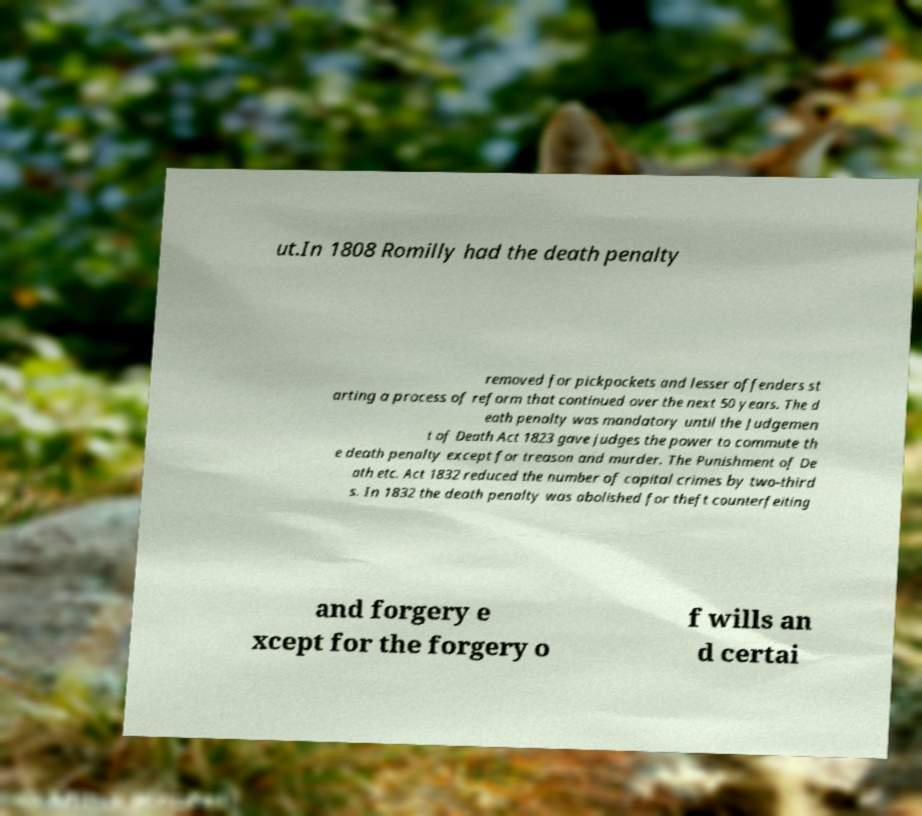Please read and relay the text visible in this image. What does it say? ut.In 1808 Romilly had the death penalty removed for pickpockets and lesser offenders st arting a process of reform that continued over the next 50 years. The d eath penalty was mandatory until the Judgemen t of Death Act 1823 gave judges the power to commute th e death penalty except for treason and murder. The Punishment of De ath etc. Act 1832 reduced the number of capital crimes by two-third s. In 1832 the death penalty was abolished for theft counterfeiting and forgery e xcept for the forgery o f wills an d certai 